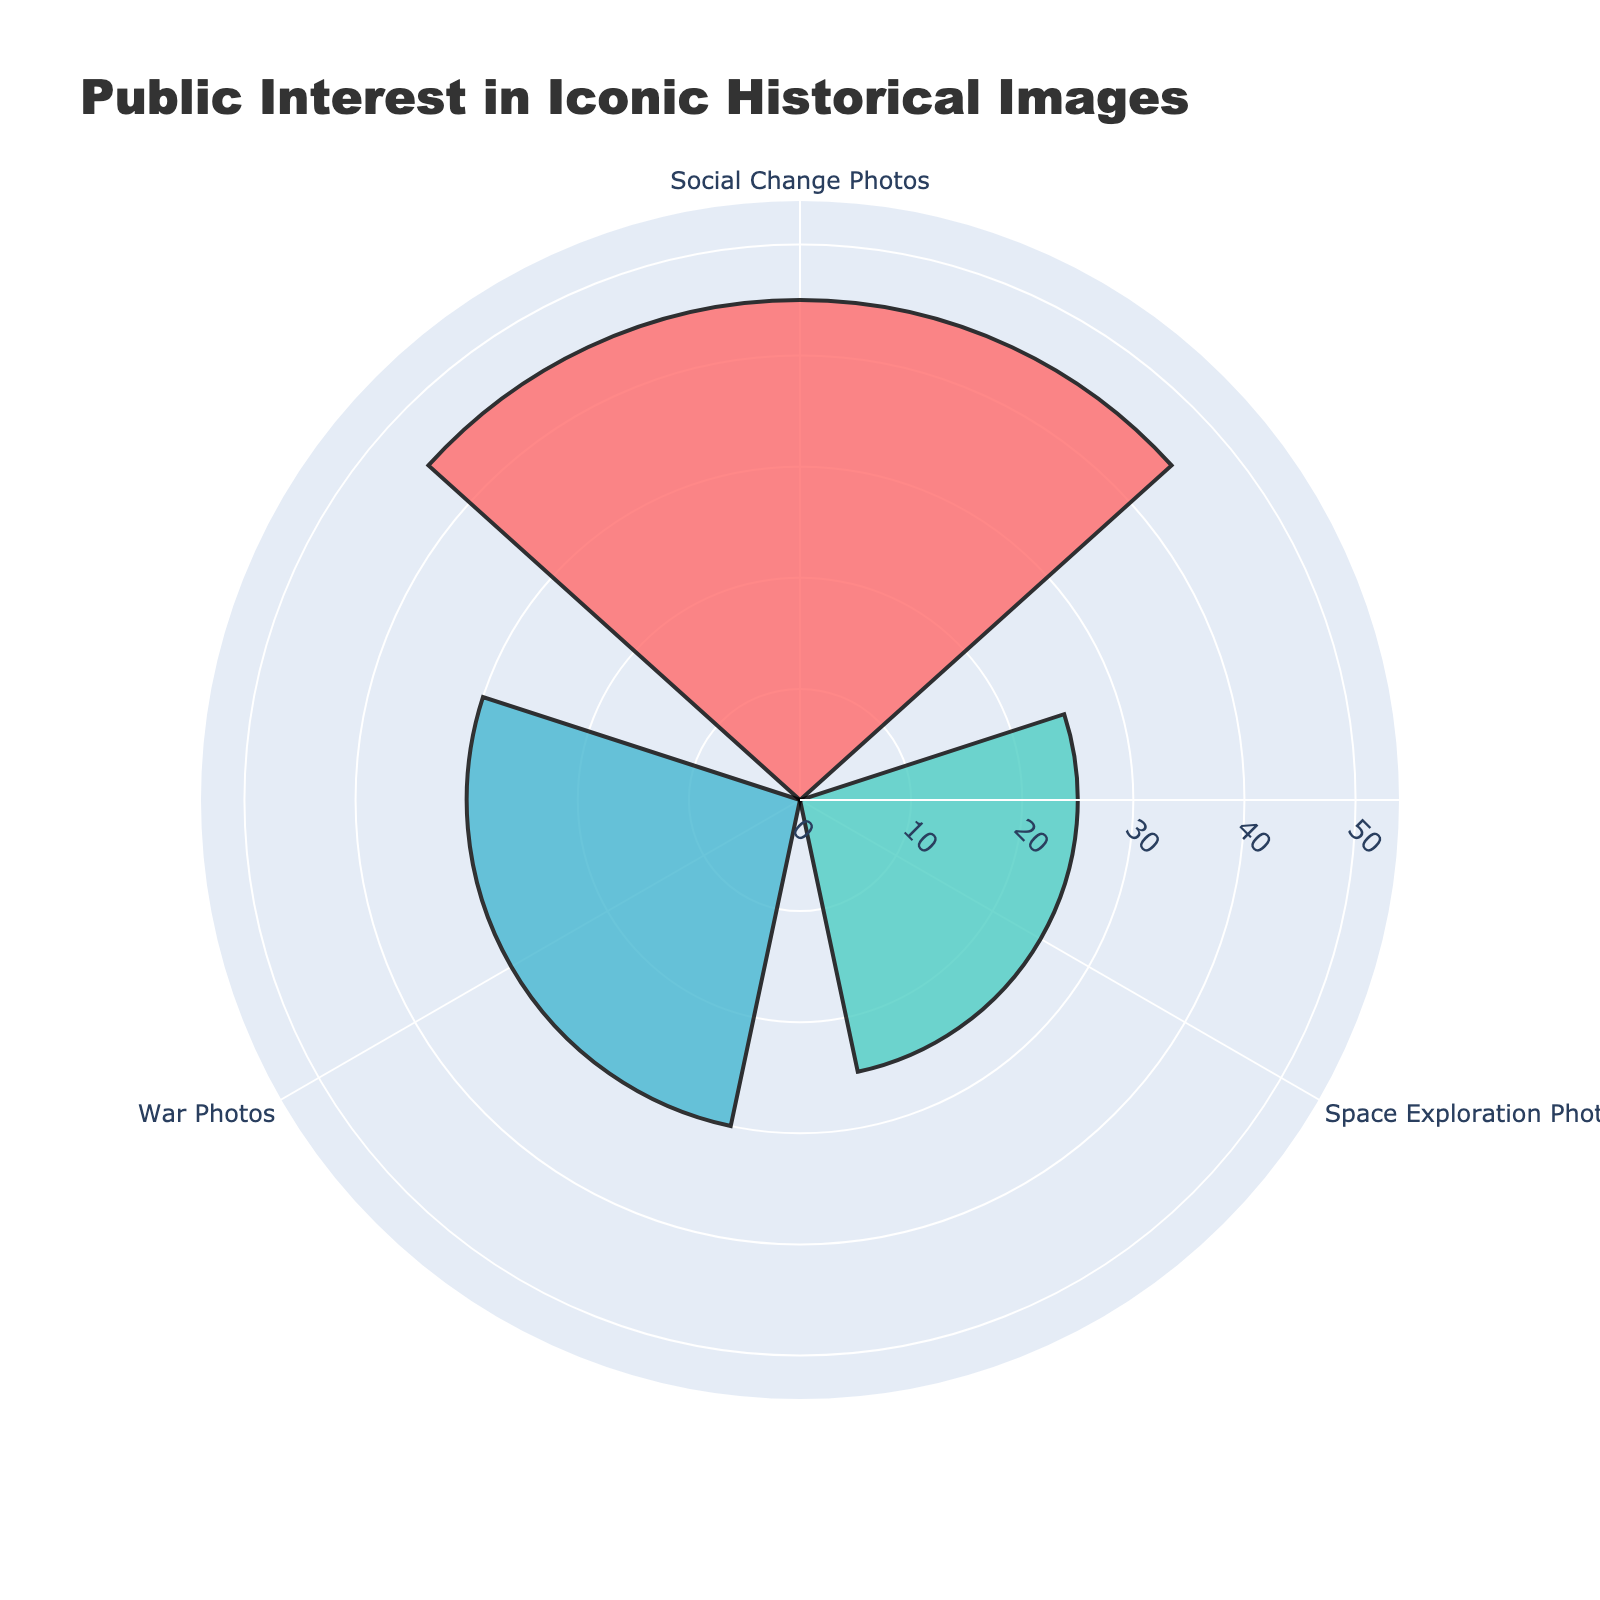What is the title of the figure? The title is usually found at the top of the figure. In this case, it is displayed prominently within the layout design of the plot.
Answer: Public Interest in Iconic Historical Images How many groups are displayed in the rose chart? To find the number of groups, look at the different colored segments or the annotations on the rose chart indicating group names. There are three distinct groups here.
Answer: 3 Which group has the highest percentage interest? Examine the lengths of the bars in the rose chart, as the longest bar represents the group with the highest percentage interest. The group name is provided via annotation.
Answer: Social Change Photos How much more interest does the group with the highest percentage have compared to the least interested group? Identify the highest and lowest percentage values from the annotations. Subtract the smallest value (War Photos: 30%) from the largest value (Social Change Photos: 45%).
Answer: 15% What are the three groups represented in the chart? Read the labels and annotations that indicate the names of the groups. The three groups are War Photos, Social Change Photos, and Space Exploration Photos.
Answer: War Photos, Social Change Photos, Space Exploration Photos Which color represents the 'War Photos' group? Look at the color-coded segments and match them with the corresponding group names. 'War Photos' are represented by the color maroon (or dark red).
Answer: Maroon Is the 'War Photos' group's percentage interest greater than that of the 'Space Exploration Photos' group? Compare the percentage interest of 'War Photos' and 'Space Exploration Photos' by identifying their respective values from the annotations. War Photos has 30% while Space Exploration Photos has 25%. Since 30% is greater than 25%, the answer is yes.
Answer: Yes What is the combined percentage interest for all groups? Sum the percentage interests for all groups: War Photos (30%) + Social Change Photos (45%) + Space Exploration Photos (25%).
Answer: 100% What is the difference in percentage interest between 'Social Change Photos' and 'Space Exploration Photos'? Subtract the percentage interest of 'Space Exploration Photos' (25%) from that of 'Social Change Photos' (45%).
Answer: 20% How is the information about the percentage interests displayed visually in the chart? The percentage interests are visually represented by the lengths of the bars extending from the center of the rose chart. The longer the bar, the higher the percentage interest.
Answer: As lengths of bars 